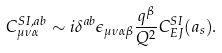Convert formula to latex. <formula><loc_0><loc_0><loc_500><loc_500>C _ { \mu \nu \alpha } ^ { S I , a b } \sim i \delta ^ { a b } \epsilon _ { \mu \nu \alpha \beta } \frac { q ^ { \beta } } { Q ^ { 2 } } C _ { E J } ^ { S I } ( a _ { s } ) .</formula> 